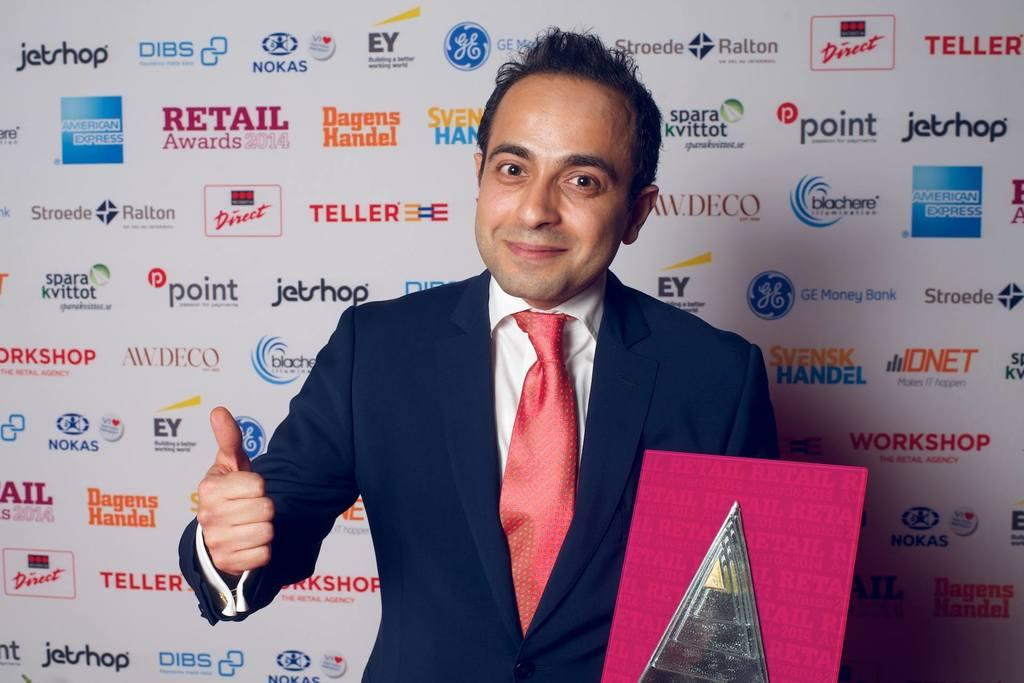What is the appearance of the person in the image? The person in the image is wearing a suit. What is the person doing in the image? The person is standing in the image. What is the person holding in his hand? The person is holding an object in his hand. What else can be seen in the image besides the person? There is a banner in the image. What type of toy is the person playing with in the image? There is no toy present in the image, and the person is not shown playing with anything. 